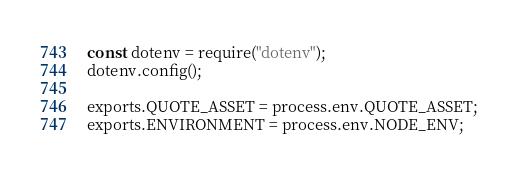<code> <loc_0><loc_0><loc_500><loc_500><_JavaScript_>const dotenv = require("dotenv");
dotenv.config();

exports.QUOTE_ASSET = process.env.QUOTE_ASSET;
exports.ENVIRONMENT = process.env.NODE_ENV;
</code> 